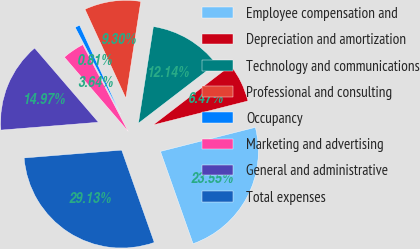<chart> <loc_0><loc_0><loc_500><loc_500><pie_chart><fcel>Employee compensation and<fcel>Depreciation and amortization<fcel>Technology and communications<fcel>Professional and consulting<fcel>Occupancy<fcel>Marketing and advertising<fcel>General and administrative<fcel>Total expenses<nl><fcel>23.55%<fcel>6.47%<fcel>12.14%<fcel>9.3%<fcel>0.81%<fcel>3.64%<fcel>14.97%<fcel>29.13%<nl></chart> 